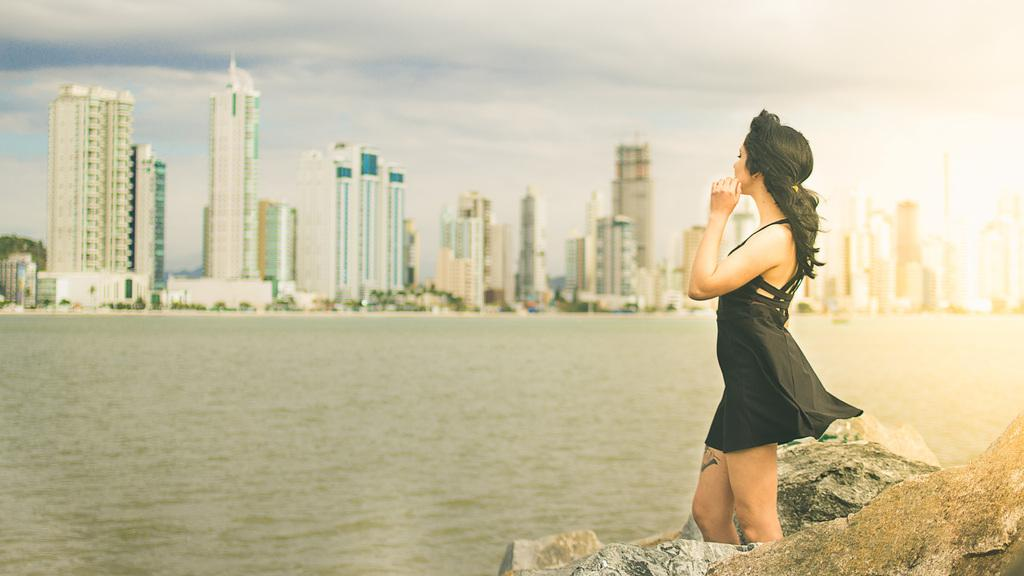What is present in the image that is not solid? There is water in the image. What is the woman in the image wearing? The woman is wearing a black dress in the image. What can be seen at the top of the image? The sky is visible at the top of the image. What type of natural formation is present in the image? There are rocks in the image. What type of man-made structures can be seen in the background of the image? There are buildings in the background of the image. What is the price of the plane in the image? There is no plane present in the image, so it is not possible to determine its price. 